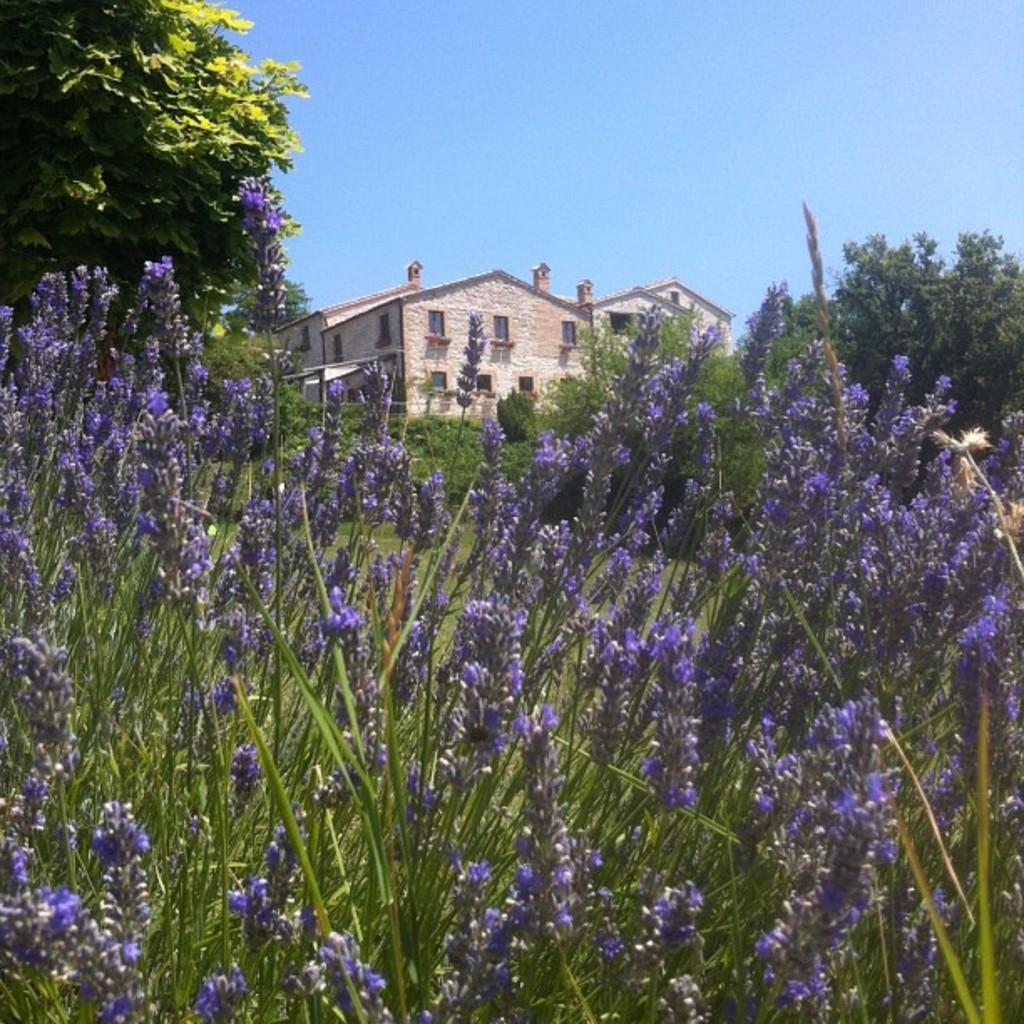Please provide a concise description of this image. In this picture we can see a few violet color flowers and plants from left to right. There are trees visible on the right and left side of the image. We can see a building and a tree in the background. Sky is blue in color. 